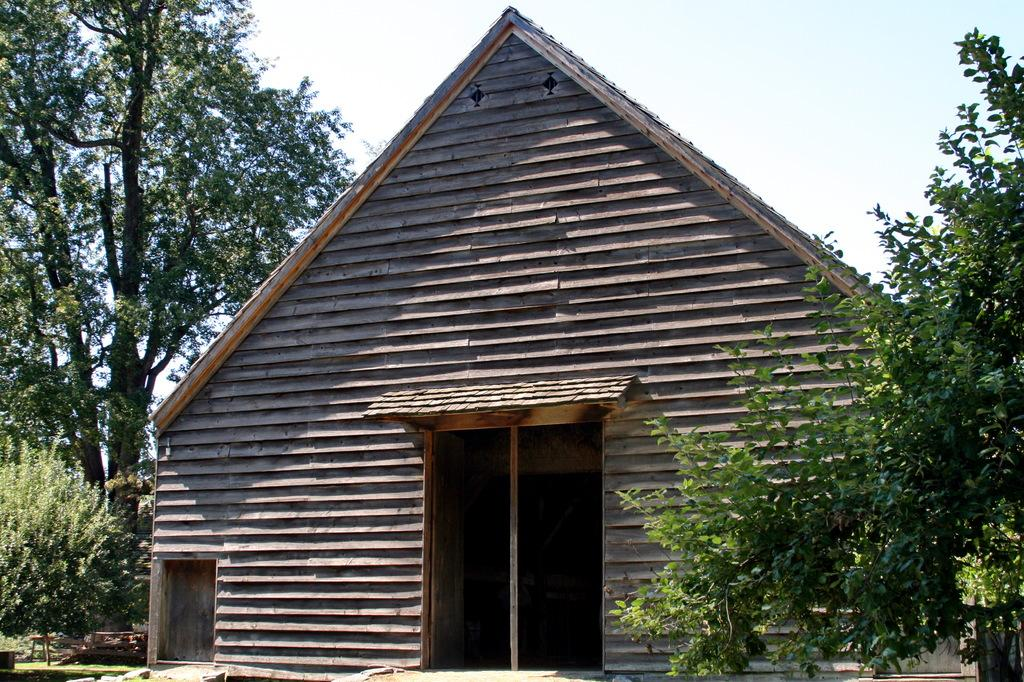What type of house is in the image? There is a wooden house in the image. What can be seen on the left side of the image? There are trees on the left side of the image. What can be seen on the right side of the image? There are trees on the right side of the image. What is visible in the background of the image? The sky is visible in the background of the image. Can you see any planes flying in the sky in the image? There are no planes visible in the sky in the image. Is there a pig present in the image? There is no pig present in the image. 